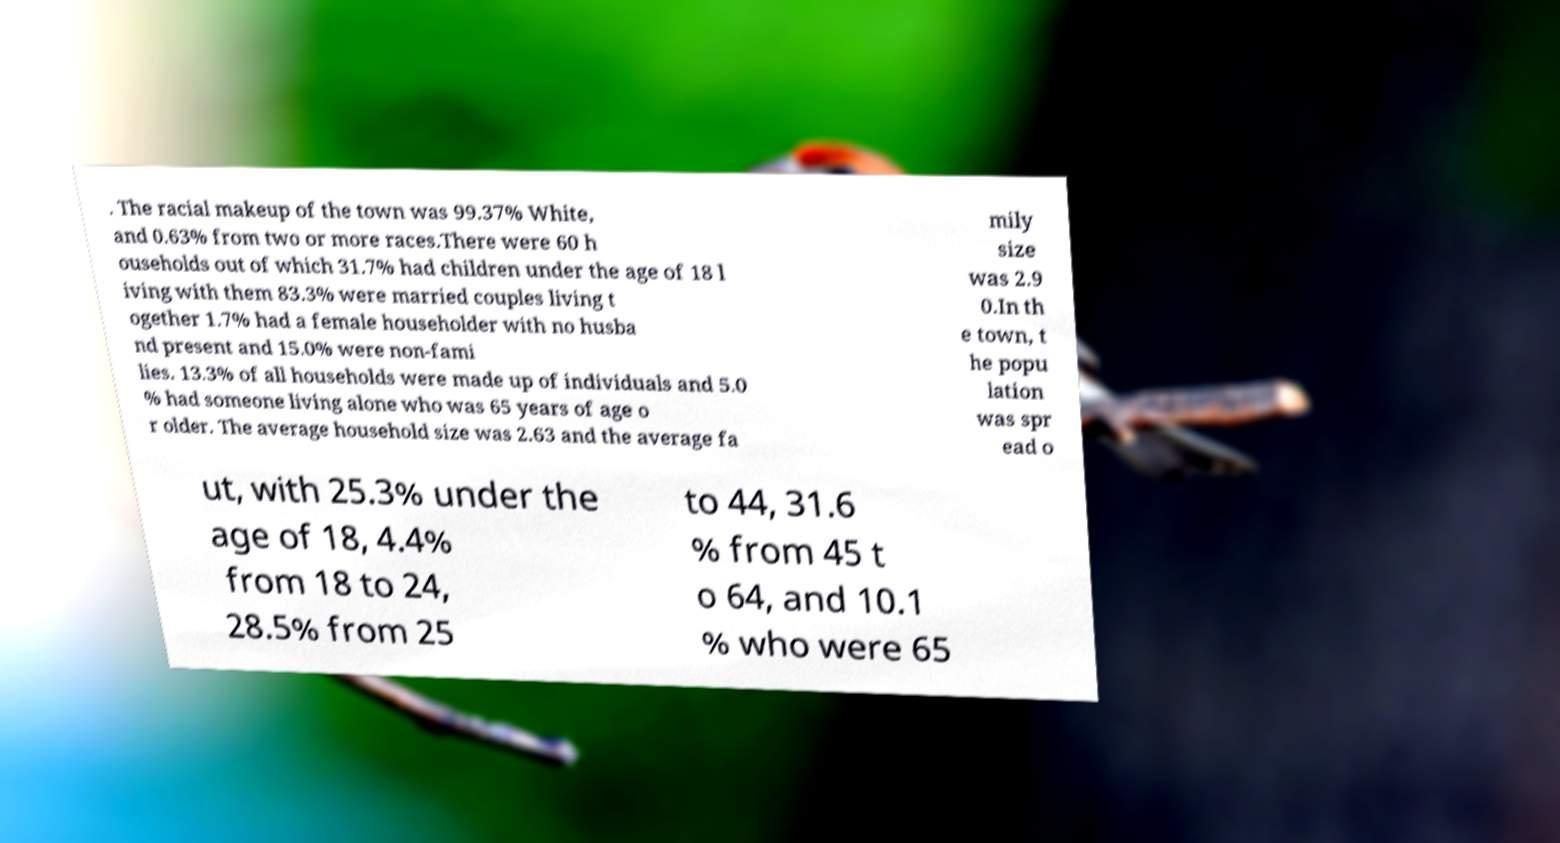Could you assist in decoding the text presented in this image and type it out clearly? . The racial makeup of the town was 99.37% White, and 0.63% from two or more races.There were 60 h ouseholds out of which 31.7% had children under the age of 18 l iving with them 83.3% were married couples living t ogether 1.7% had a female householder with no husba nd present and 15.0% were non-fami lies. 13.3% of all households were made up of individuals and 5.0 % had someone living alone who was 65 years of age o r older. The average household size was 2.63 and the average fa mily size was 2.9 0.In th e town, t he popu lation was spr ead o ut, with 25.3% under the age of 18, 4.4% from 18 to 24, 28.5% from 25 to 44, 31.6 % from 45 t o 64, and 10.1 % who were 65 